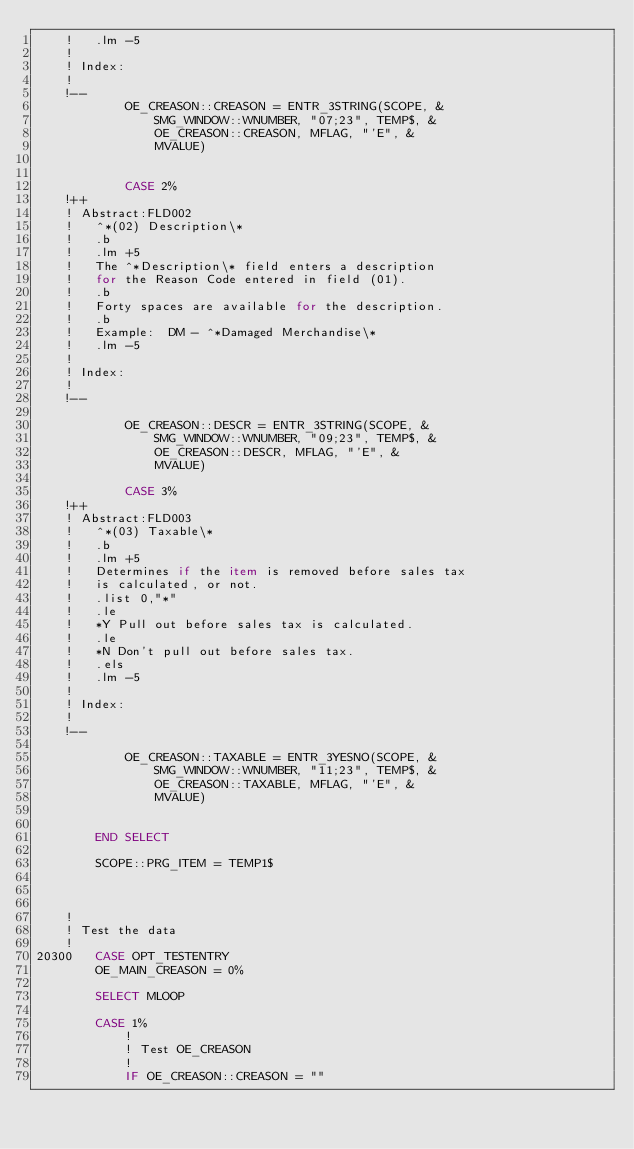Convert code to text. <code><loc_0><loc_0><loc_500><loc_500><_VisualBasic_>	!	.lm -5
	!
	! Index:
	!
	!--
			OE_CREASON::CREASON = ENTR_3STRING(SCOPE, &
				SMG_WINDOW::WNUMBER, "07;23", TEMP$, &
				OE_CREASON::CREASON, MFLAG, "'E", &
				MVALUE)


			CASE 2%
	!++
	! Abstract:FLD002
	!	^*(02) Description\*
	!	.b
	!	.lm +5
	!	The ^*Description\* field enters a description
	!	for the Reason Code entered in field (01).
	!	.b
	!	Forty spaces are available for the description.
	!	.b
	!	Example:  DM - ^*Damaged Merchandise\*
	!	.lm -5
	!
	! Index:
	!
	!--

			OE_CREASON::DESCR = ENTR_3STRING(SCOPE, &
				SMG_WINDOW::WNUMBER, "09;23", TEMP$, &
				OE_CREASON::DESCR, MFLAG, "'E", &
				MVALUE)

			CASE 3%
	!++
	! Abstract:FLD003
	!	^*(03) Taxable\*
	!	.b
	!	.lm +5
	!	Determines if the item is removed before sales tax
	!	is calculated, or not.
	!	.list 0,"*"
	!	.le
	!	*Y Pull out before sales tax is calculated.
	!	.le
	!	*N Don't pull out before sales tax.
	!	.els
	!	.lm -5
	!
	! Index:
	!
	!--

			OE_CREASON::TAXABLE = ENTR_3YESNO(SCOPE, &
				SMG_WINDOW::WNUMBER, "11;23", TEMP$, &
				OE_CREASON::TAXABLE, MFLAG, "'E", &
				MVALUE)


		END SELECT

		SCOPE::PRG_ITEM = TEMP1$



	!
	! Test the data
	!
20300	CASE OPT_TESTENTRY
		OE_MAIN_CREASON = 0%

		SELECT MLOOP

		CASE 1%
			!
			! Test OE_CREASON
			!
			IF OE_CREASON::CREASON = ""</code> 